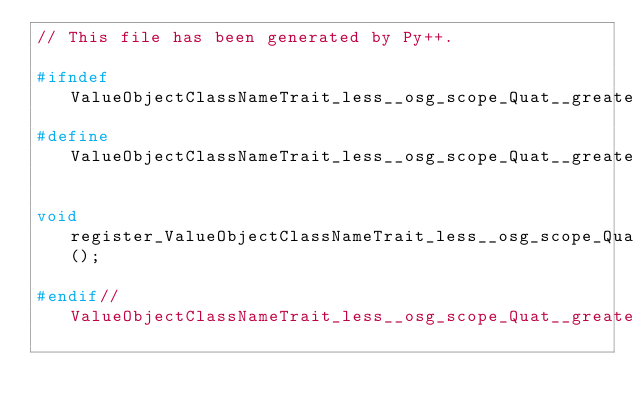<code> <loc_0><loc_0><loc_500><loc_500><_C++_>// This file has been generated by Py++.

#ifndef ValueObjectClassNameTrait_less__osg_scope_Quat__greater__hpp__pyplusplus_wrapper
#define ValueObjectClassNameTrait_less__osg_scope_Quat__greater__hpp__pyplusplus_wrapper

void register_ValueObjectClassNameTrait_less__osg_scope_Quat__greater__class();

#endif//ValueObjectClassNameTrait_less__osg_scope_Quat__greater__hpp__pyplusplus_wrapper
</code> 